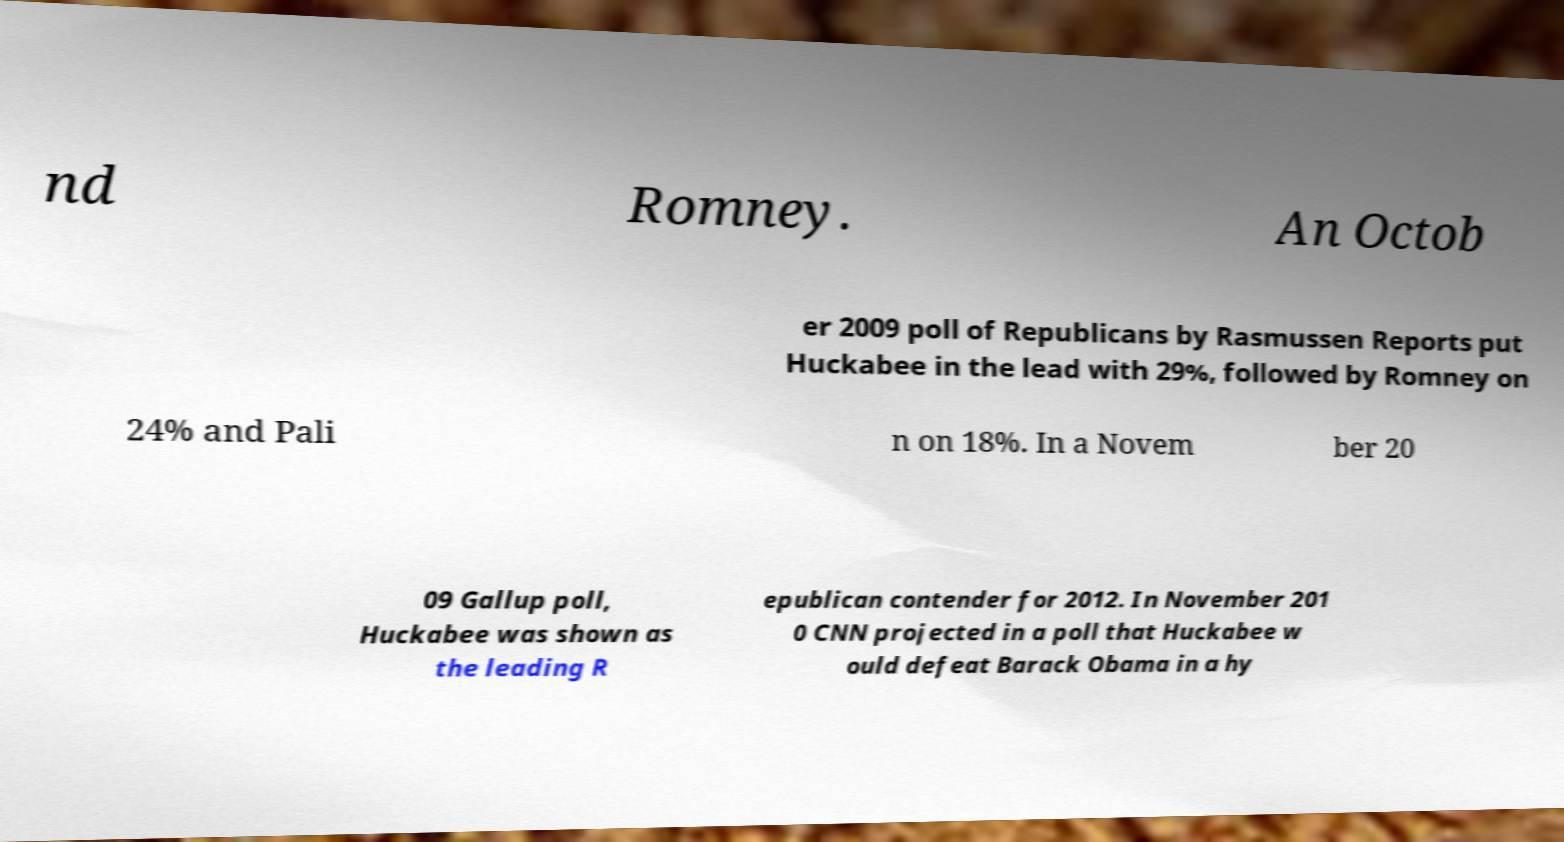I need the written content from this picture converted into text. Can you do that? nd Romney. An Octob er 2009 poll of Republicans by Rasmussen Reports put Huckabee in the lead with 29%, followed by Romney on 24% and Pali n on 18%. In a Novem ber 20 09 Gallup poll, Huckabee was shown as the leading R epublican contender for 2012. In November 201 0 CNN projected in a poll that Huckabee w ould defeat Barack Obama in a hy 